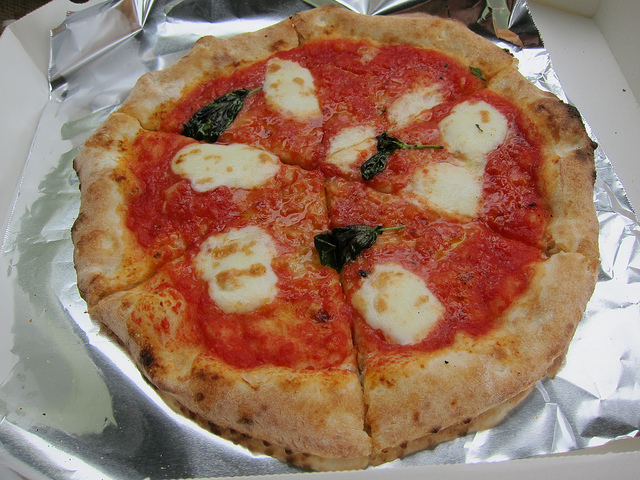<image>What vegetable is on top of the pizza? I am not sure about the vegetable on top of the pizza. It can be basil, spinach or lettuce. What vegetable is on top of the pizza? I am not sure what vegetable is on top of the pizza. It can be seen 'basil', 'spinach', 'tomato sauce' or 'lettuce'. 